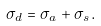<formula> <loc_0><loc_0><loc_500><loc_500>\sigma _ { d } = \sigma _ { a } + \sigma _ { s } .</formula> 